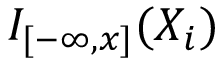<formula> <loc_0><loc_0><loc_500><loc_500>I _ { [ - \infty , x ] } ( X _ { i } )</formula> 